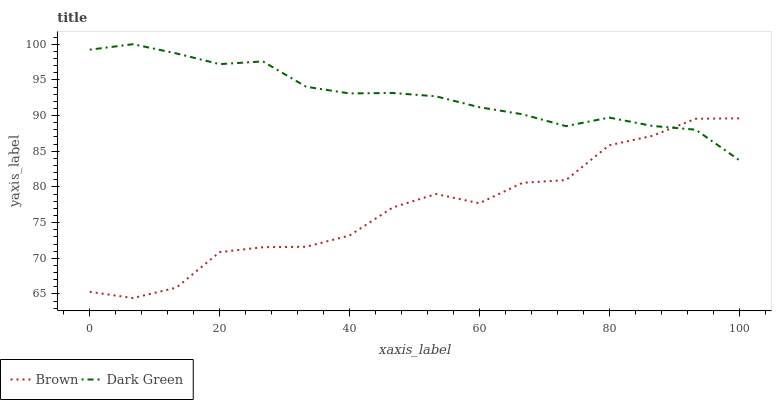Does Brown have the minimum area under the curve?
Answer yes or no. Yes. Does Dark Green have the maximum area under the curve?
Answer yes or no. Yes. Does Dark Green have the minimum area under the curve?
Answer yes or no. No. Is Dark Green the smoothest?
Answer yes or no. Yes. Is Brown the roughest?
Answer yes or no. Yes. Is Dark Green the roughest?
Answer yes or no. No. Does Brown have the lowest value?
Answer yes or no. Yes. Does Dark Green have the lowest value?
Answer yes or no. No. Does Dark Green have the highest value?
Answer yes or no. Yes. Does Dark Green intersect Brown?
Answer yes or no. Yes. Is Dark Green less than Brown?
Answer yes or no. No. Is Dark Green greater than Brown?
Answer yes or no. No. 